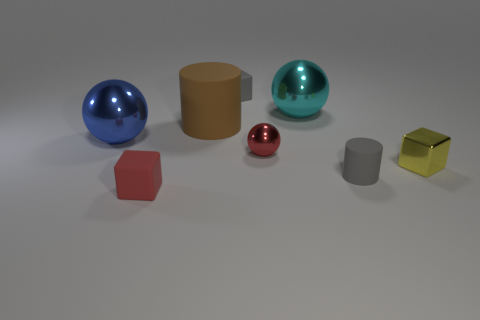Add 1 tiny objects. How many objects exist? 9 Subtract all spheres. How many objects are left? 5 Add 5 big cylinders. How many big cylinders exist? 6 Subtract 0 brown blocks. How many objects are left? 8 Subtract all matte cylinders. Subtract all tiny rubber cylinders. How many objects are left? 5 Add 7 large shiny objects. How many large shiny objects are left? 9 